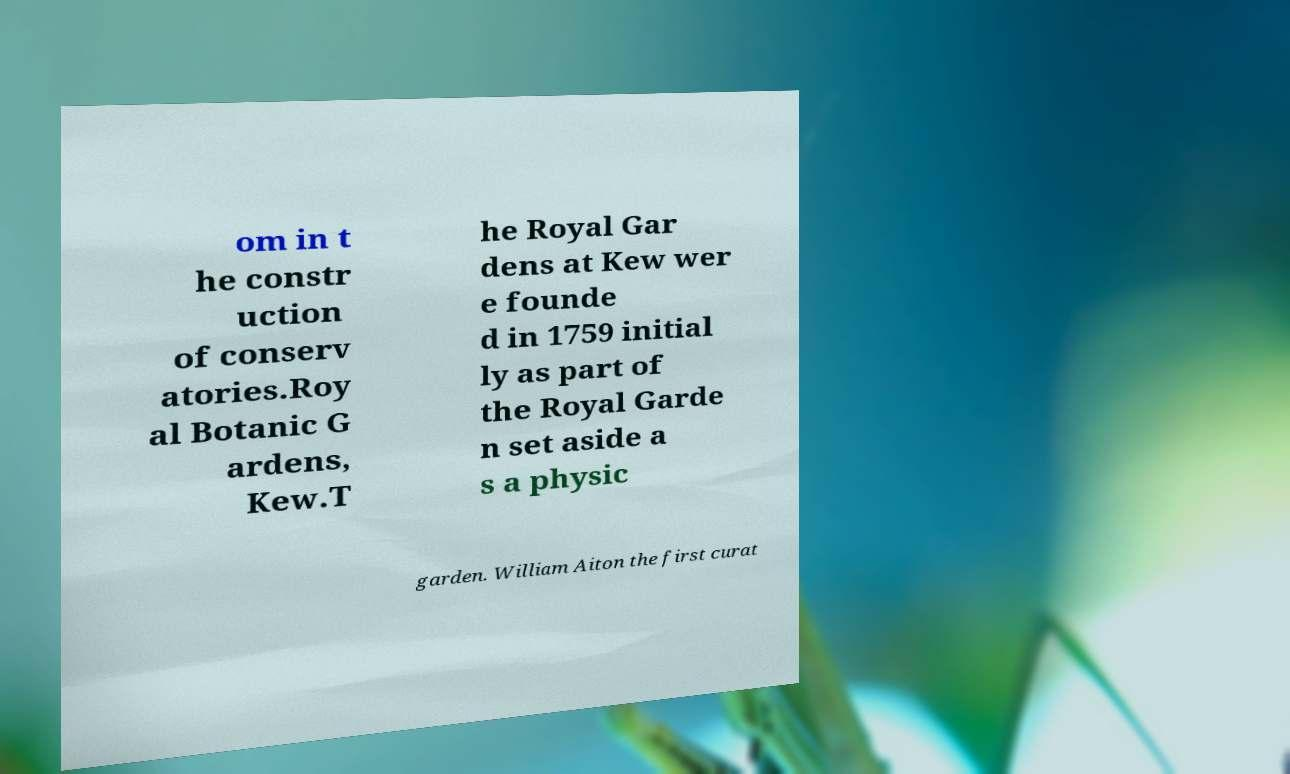Can you read and provide the text displayed in the image?This photo seems to have some interesting text. Can you extract and type it out for me? om in t he constr uction of conserv atories.Roy al Botanic G ardens, Kew.T he Royal Gar dens at Kew wer e founde d in 1759 initial ly as part of the Royal Garde n set aside a s a physic garden. William Aiton the first curat 